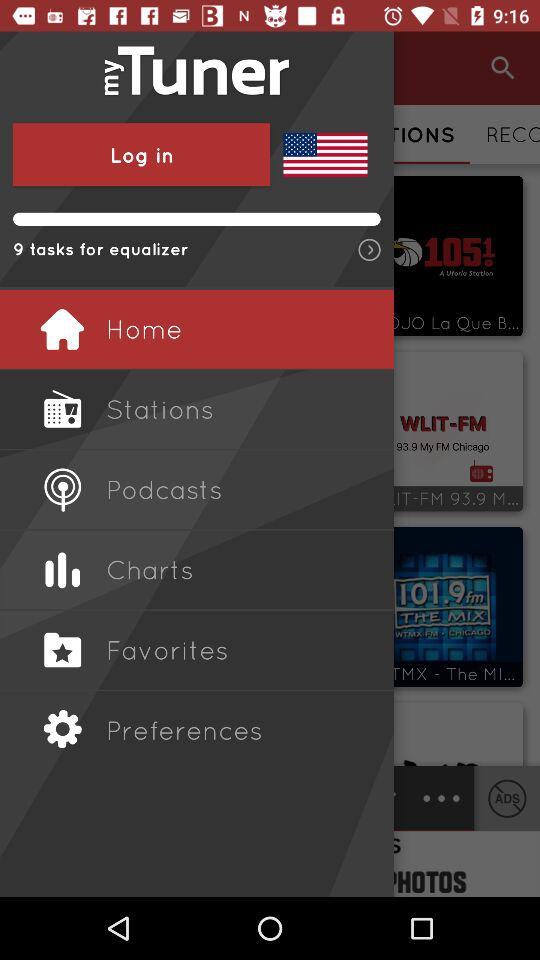What is the application name? The application name is "myTuner". 